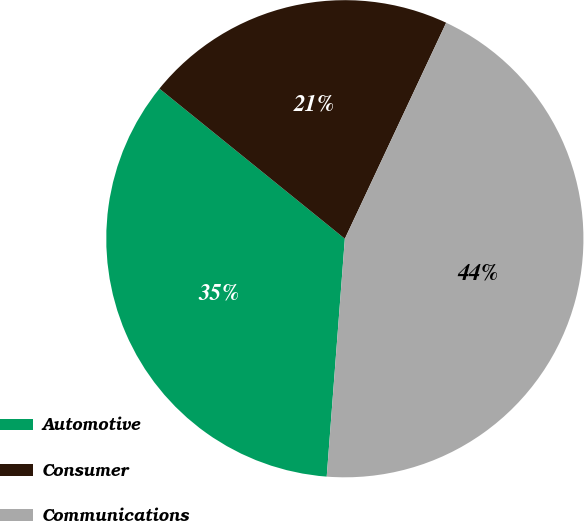Convert chart to OTSL. <chart><loc_0><loc_0><loc_500><loc_500><pie_chart><fcel>Automotive<fcel>Consumer<fcel>Communications<nl><fcel>34.62%<fcel>21.15%<fcel>44.23%<nl></chart> 